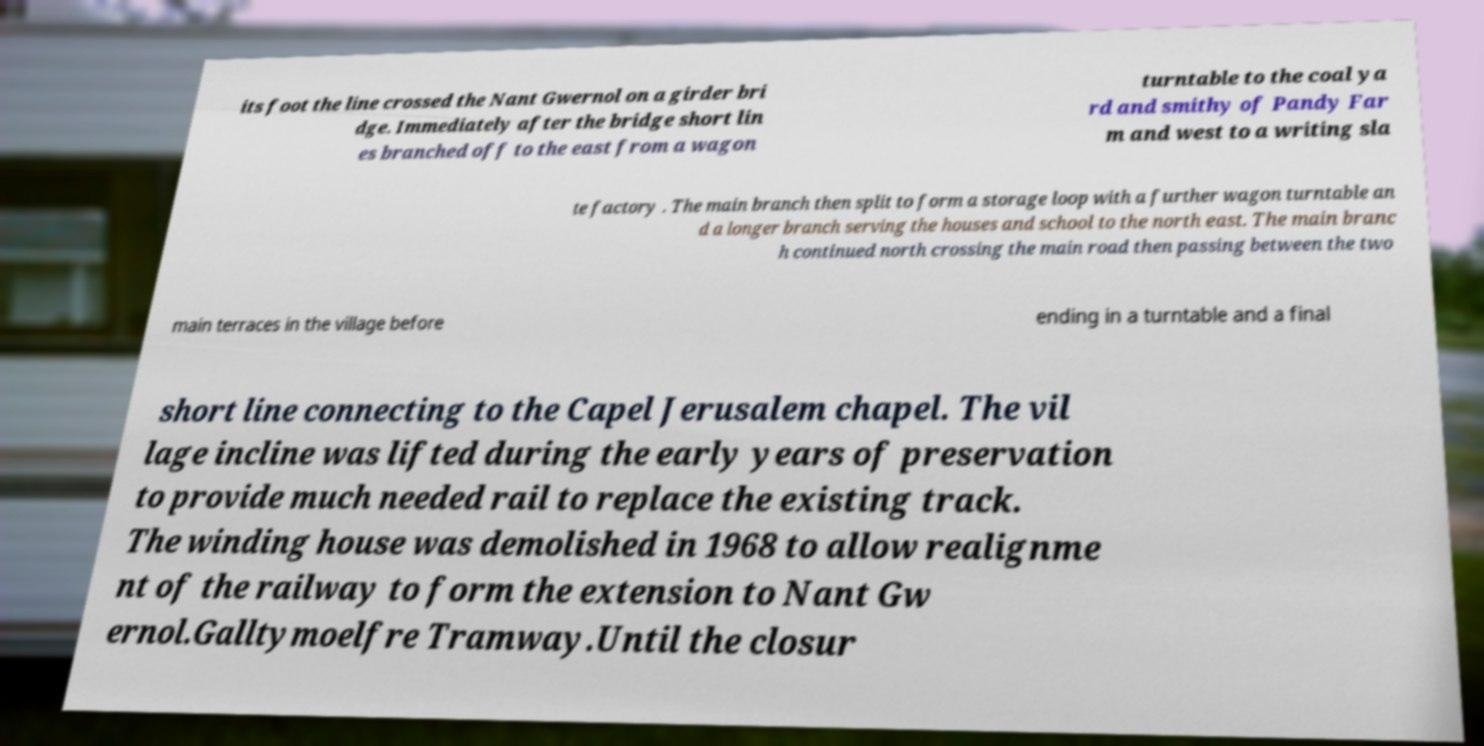Please read and relay the text visible in this image. What does it say? its foot the line crossed the Nant Gwernol on a girder bri dge. Immediately after the bridge short lin es branched off to the east from a wagon turntable to the coal ya rd and smithy of Pandy Far m and west to a writing sla te factory . The main branch then split to form a storage loop with a further wagon turntable an d a longer branch serving the houses and school to the north east. The main branc h continued north crossing the main road then passing between the two main terraces in the village before ending in a turntable and a final short line connecting to the Capel Jerusalem chapel. The vil lage incline was lifted during the early years of preservation to provide much needed rail to replace the existing track. The winding house was demolished in 1968 to allow realignme nt of the railway to form the extension to Nant Gw ernol.Galltymoelfre Tramway.Until the closur 